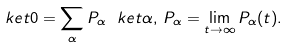Convert formula to latex. <formula><loc_0><loc_0><loc_500><loc_500>\ k e t 0 = \sum _ { \alpha } P _ { \alpha } \ k e t \alpha , \, P _ { \alpha } = \lim _ { t \to \infty } P _ { \alpha } ( t ) .</formula> 